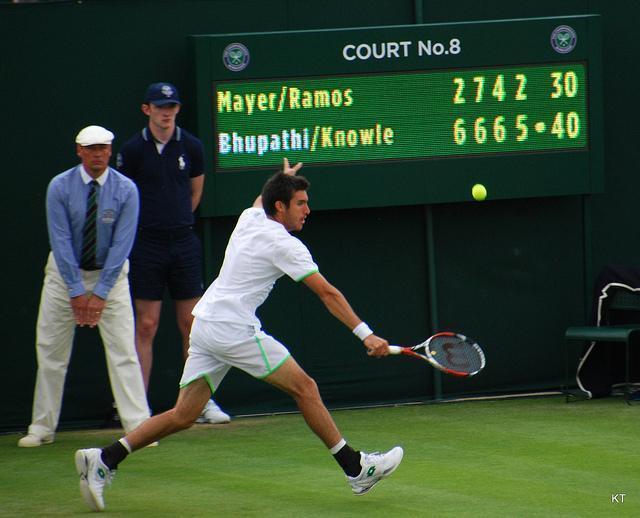How many persons are wearing hats?
Give a very brief answer. 2. How many people can you see?
Give a very brief answer. 3. How many birds are standing in the water?
Give a very brief answer. 0. 